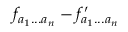<formula> <loc_0><loc_0><loc_500><loc_500>f _ { a _ { 1 } \dots a _ { n } } - f _ { a _ { 1 } \dots a _ { n } } ^ { \prime }</formula> 